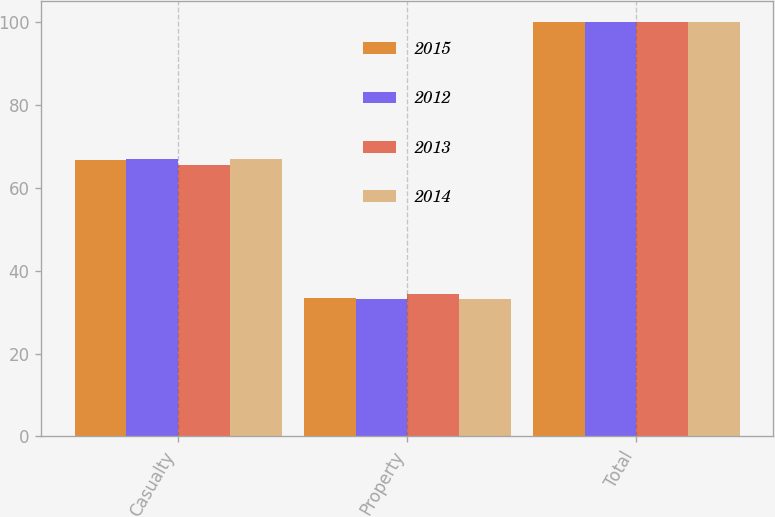Convert chart to OTSL. <chart><loc_0><loc_0><loc_500><loc_500><stacked_bar_chart><ecel><fcel>Casualty<fcel>Property<fcel>Total<nl><fcel>2015<fcel>66.7<fcel>33.3<fcel>100<nl><fcel>2012<fcel>66.9<fcel>33.1<fcel>100<nl><fcel>2013<fcel>65.6<fcel>34.4<fcel>100<nl><fcel>2014<fcel>66.9<fcel>33.1<fcel>100<nl></chart> 